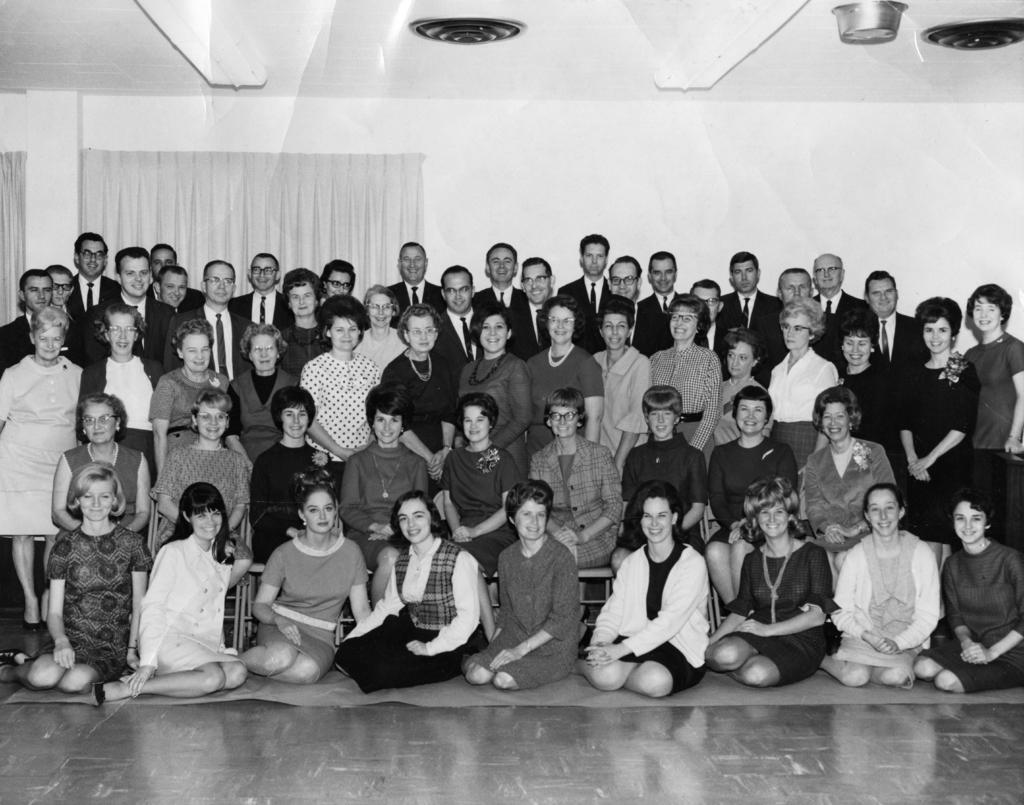Please provide a concise description of this image. This is a black and white image and it is an inside view. Here I can see a crowd of people are smiling and giving pose for the picture. In the front few people are sitting on the floor. In the middle few people are sitting on the chairs. In the background few people are standing. In the background there is a wall and I can see a curtain. 